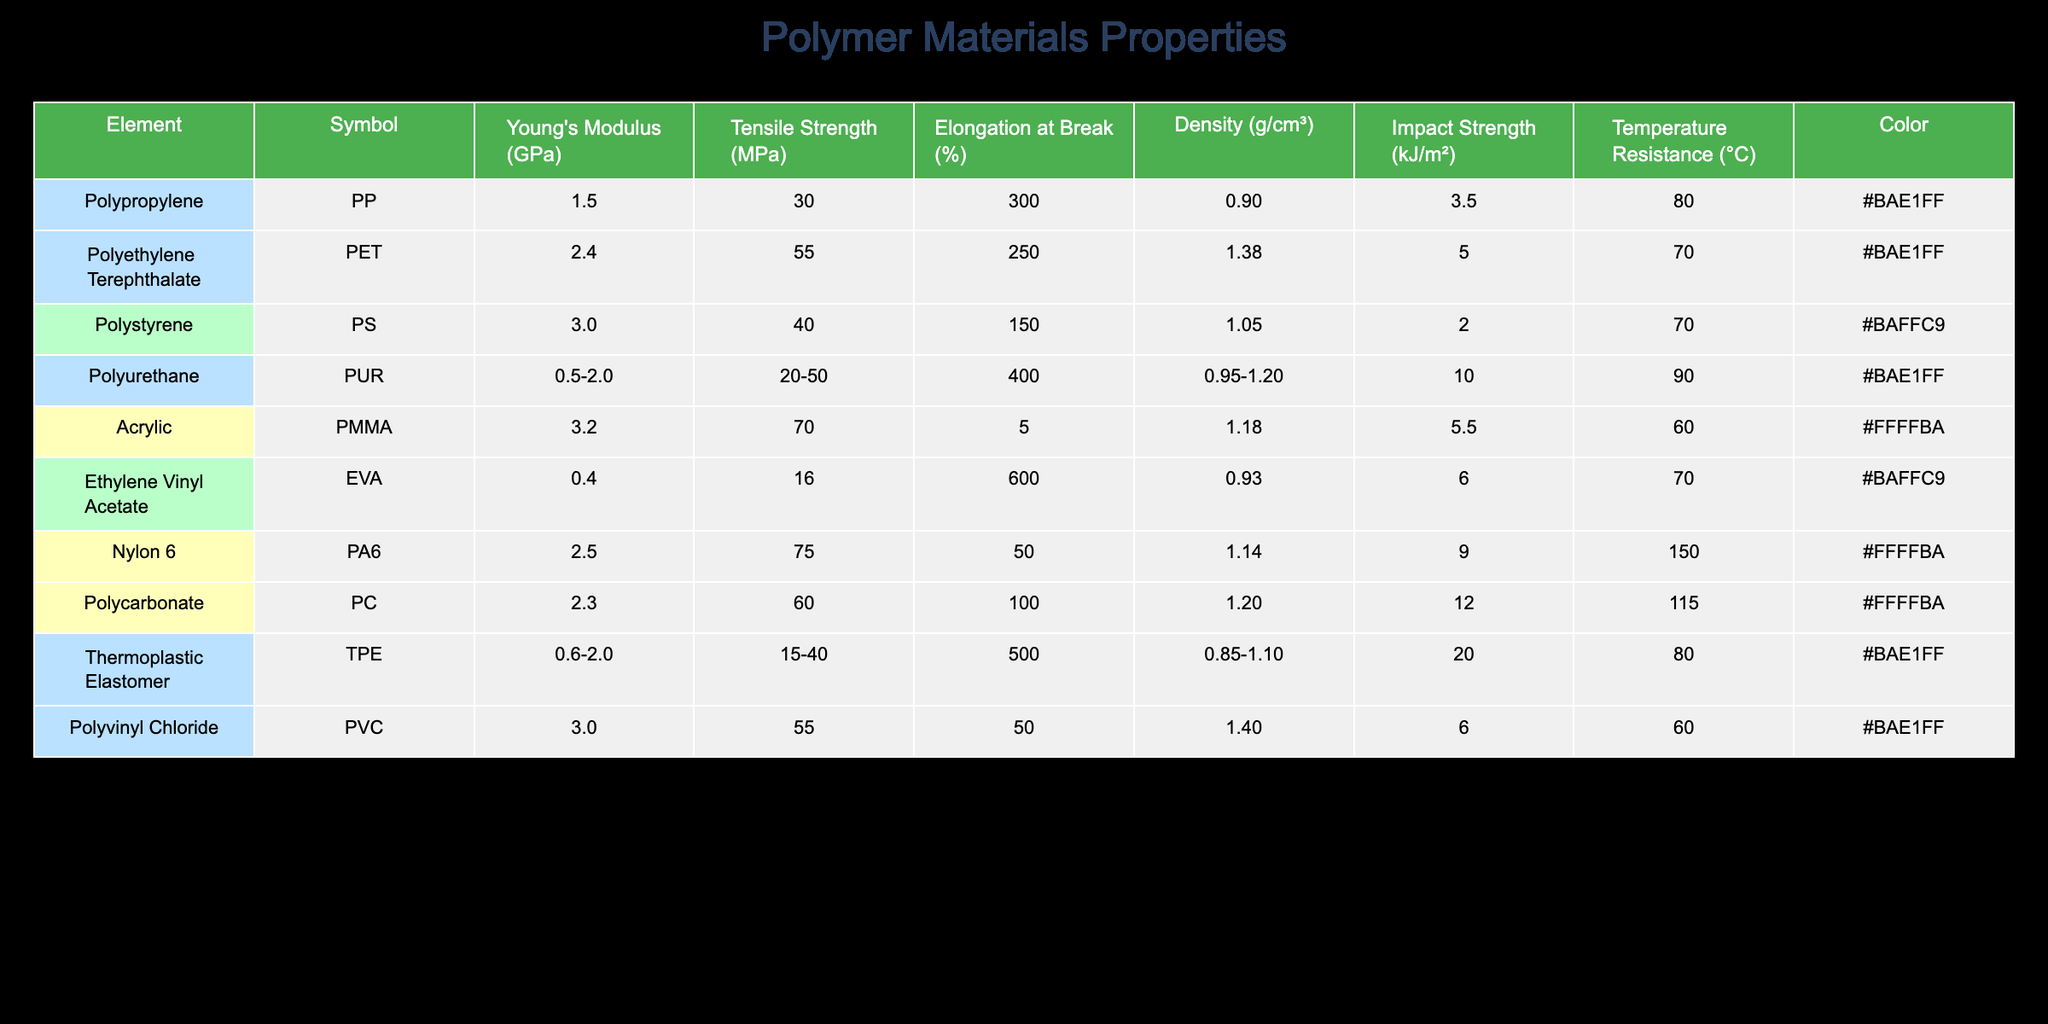What is the Young's modulus of Polycarbonate? From the table, Polycarbonate is listed with a Young's modulus of 2.3 GPa. This value can be directly found in the row corresponding to Polycarbonate in the overall data.
Answer: 2.3 GPa Which polymer has the highest impact strength? By examining the "Impact Strength" column in the table, Polyurethane shows an impact strength of 10.0 kJ/m², which is the highest among all the polymers listed. Other values were lower, confirming that Polyurethane has the highest impact strength.
Answer: 10.0 kJ/m² Is the Density of Nylon 6 greater than that of Polyvinyl Chloride? Looking at the "Density" column, Nylon 6 has a density of 1.14 g/cm³, while Polyvinyl Chloride has a density of 1.40 g/cm³. Since 1.14 is less than 1.40, the statement is false.
Answer: No What is the average Tensile Strength of the polymers listed? Adding all the values from the "Tensile Strength" column yields: 30 + 55 + 40 + 35 + 70 + 16 + 75 + 60 + 55 = 436. There are 9 polymers, therefore the average tensile strength is 436/9 = ~48.44.
Answer: ~48.44 MPa Does Polypropylene have better elongation at break than Acrylic? Checking the "Elongation at Break" values, Polypropylene has 300% while Acrylic has only 5%. Since 300% is greater than 5%, the statement is true.
Answer: Yes Which material can withstand the highest temperature? In the "Temperature Resistance" column, Nylon 6 shows the highest resistance at 150°C. This is compared against the others, which all have lower maximum temperatures.
Answer: 150°C What is the difference in Elongation at Break between Ethylene Vinyl Acetate and Polystyrene? The values for Ethylene Vinyl Acetate and Polystyrene are 600% and 150%, respectively. The difference can be calculated as 600 - 150 = 450%. Thus, Ethylene Vinyl Acetate has a significantly higher elongation at break.
Answer: 450% Which polymer has the lowest Young's modulus? From the "Young's Modulus" column, the lowest value is for Ethylene Vinyl Acetate (EVA) with a value of 0.4 GPa. This is identified easily as it is the smallest number in that column.
Answer: 0.4 GPa What are the impact strengths of the two polymers with the highest tensile strength? The two highest values for tensile strength are for Nylon 6 (75 MPa) and Polycarbonate (60 MPa). Their corresponding impact strengths are 9.0 kJ/m² and 12.0 kJ/m². Therefore, the impact strengths are 9.0 kJ/m² and 12.0 kJ/m².
Answer: 9.0 kJ/m² and 12.0 kJ/m² 